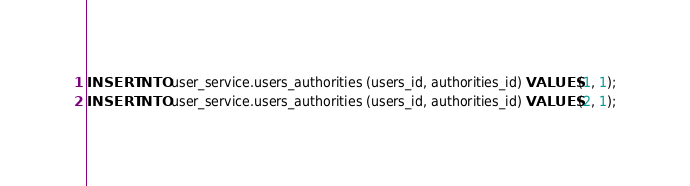Convert code to text. <code><loc_0><loc_0><loc_500><loc_500><_SQL_>INSERT INTO user_service.users_authorities (users_id, authorities_id) VALUES (1, 1);
INSERT INTO user_service.users_authorities (users_id, authorities_id) VALUES (2, 1);</code> 